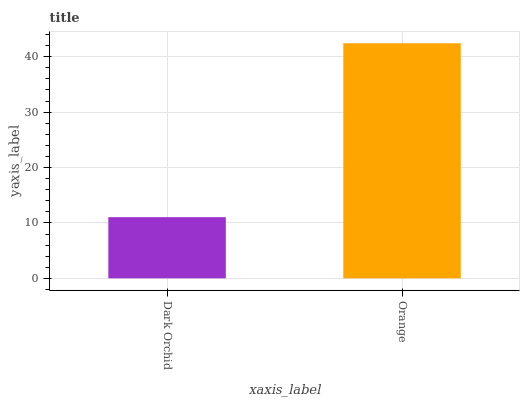Is Dark Orchid the minimum?
Answer yes or no. Yes. Is Orange the maximum?
Answer yes or no. Yes. Is Orange the minimum?
Answer yes or no. No. Is Orange greater than Dark Orchid?
Answer yes or no. Yes. Is Dark Orchid less than Orange?
Answer yes or no. Yes. Is Dark Orchid greater than Orange?
Answer yes or no. No. Is Orange less than Dark Orchid?
Answer yes or no. No. Is Orange the high median?
Answer yes or no. Yes. Is Dark Orchid the low median?
Answer yes or no. Yes. Is Dark Orchid the high median?
Answer yes or no. No. Is Orange the low median?
Answer yes or no. No. 